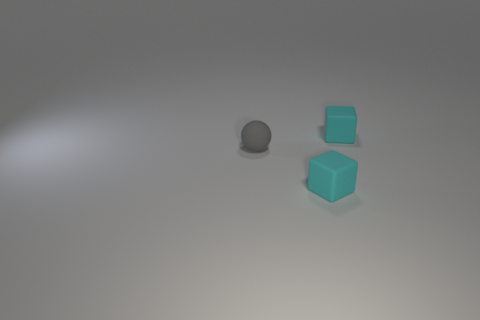Is the shape of the small cyan thing in front of the tiny ball the same as the tiny matte thing behind the tiny gray ball?
Provide a succinct answer. Yes. There is a ball; is it the same size as the cyan cube that is in front of the tiny gray matte sphere?
Your answer should be very brief. Yes. Is the number of cubes greater than the number of brown shiny things?
Your answer should be very brief. Yes. Does the small thing that is in front of the matte sphere have the same material as the block behind the small gray thing?
Give a very brief answer. Yes. What is the material of the small sphere?
Provide a short and direct response. Rubber. Are there more cyan things that are to the right of the small gray rubber object than brown things?
Offer a terse response. Yes. What number of small gray rubber things are behind the small cyan matte block behind the block that is in front of the small gray matte thing?
Offer a terse response. 0. The matte ball has what color?
Your answer should be compact. Gray. What is the color of the small block that is behind the small gray matte object?
Offer a terse response. Cyan. What number of things are green cubes or tiny gray spheres?
Make the answer very short. 1. 